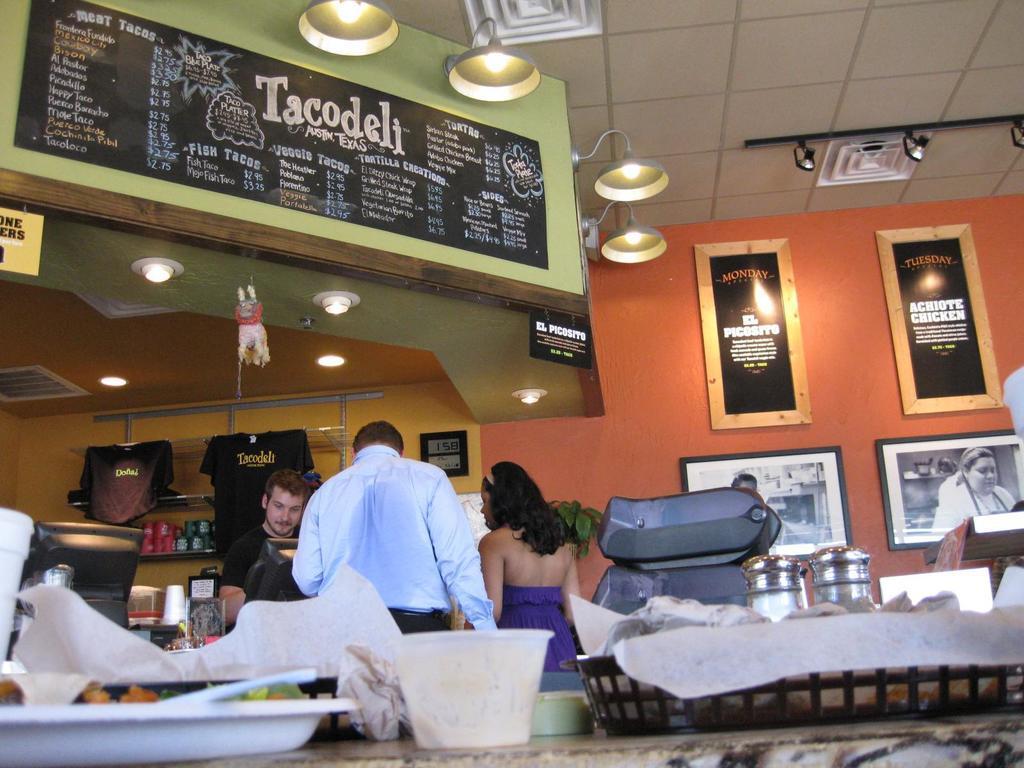Can you describe this image briefly? In the picture I can see plates, bowls and few more objects are placed on the table, I can see these three people are standing near the table, I can see the monitors and few more objects placed on the table, here I can see photo frames on the wall, I can see the boards, T-shirts hanged here, I can see some objects kept on the shelf and I can see the ceiling lights in the background. 